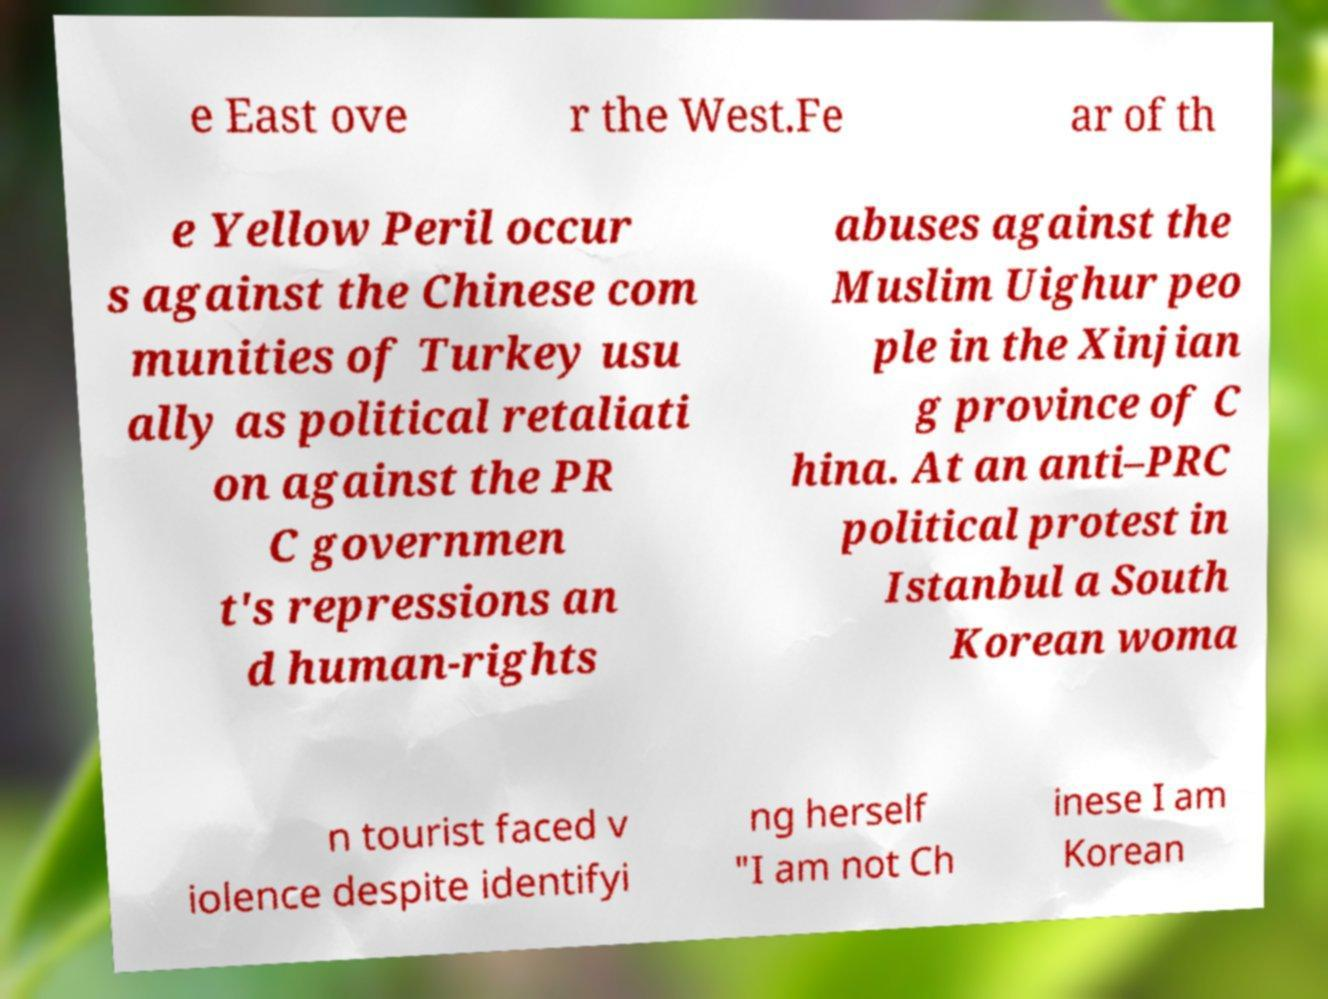Please identify and transcribe the text found in this image. e East ove r the West.Fe ar of th e Yellow Peril occur s against the Chinese com munities of Turkey usu ally as political retaliati on against the PR C governmen t's repressions an d human-rights abuses against the Muslim Uighur peo ple in the Xinjian g province of C hina. At an anti–PRC political protest in Istanbul a South Korean woma n tourist faced v iolence despite identifyi ng herself "I am not Ch inese I am Korean 